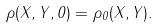Convert formula to latex. <formula><loc_0><loc_0><loc_500><loc_500>\rho ( X , Y , 0 ) = \rho _ { 0 } ( X , Y ) .</formula> 